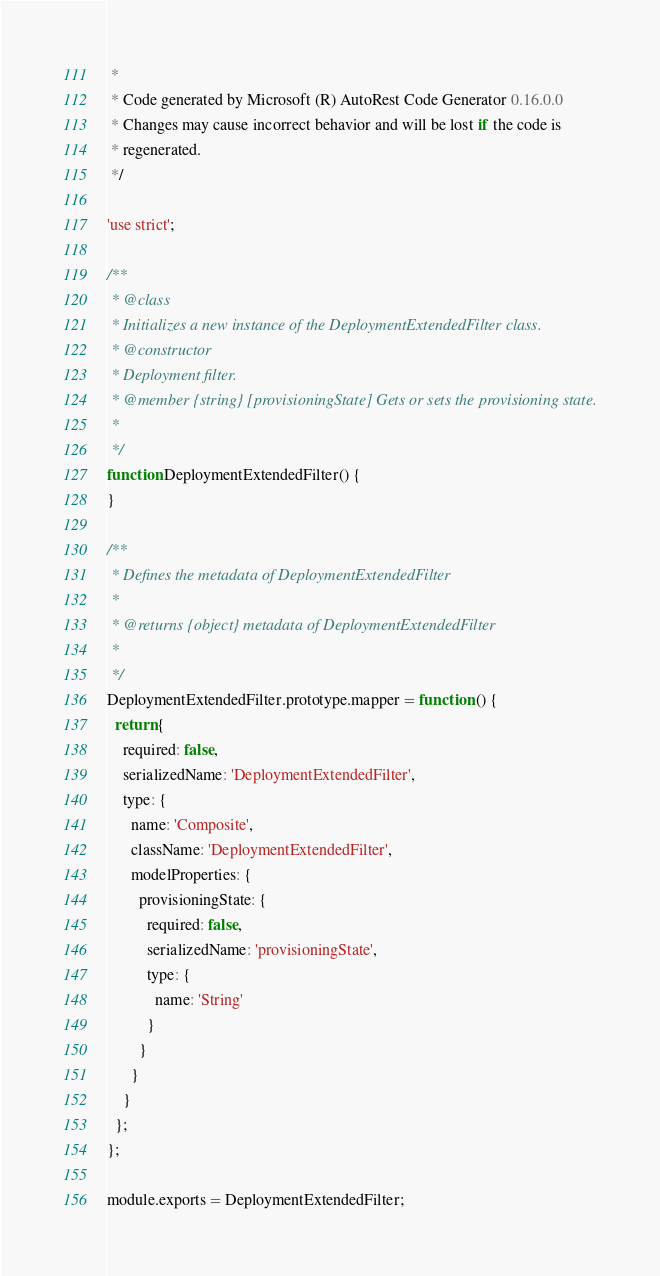<code> <loc_0><loc_0><loc_500><loc_500><_JavaScript_> * 
 * Code generated by Microsoft (R) AutoRest Code Generator 0.16.0.0
 * Changes may cause incorrect behavior and will be lost if the code is
 * regenerated.
 */

'use strict';

/**
 * @class
 * Initializes a new instance of the DeploymentExtendedFilter class.
 * @constructor
 * Deployment filter.
 * @member {string} [provisioningState] Gets or sets the provisioning state.
 * 
 */
function DeploymentExtendedFilter() {
}

/**
 * Defines the metadata of DeploymentExtendedFilter
 *
 * @returns {object} metadata of DeploymentExtendedFilter
 *
 */
DeploymentExtendedFilter.prototype.mapper = function () {
  return {
    required: false,
    serializedName: 'DeploymentExtendedFilter',
    type: {
      name: 'Composite',
      className: 'DeploymentExtendedFilter',
      modelProperties: {
        provisioningState: {
          required: false,
          serializedName: 'provisioningState',
          type: {
            name: 'String'
          }
        }
      }
    }
  };
};

module.exports = DeploymentExtendedFilter;
</code> 